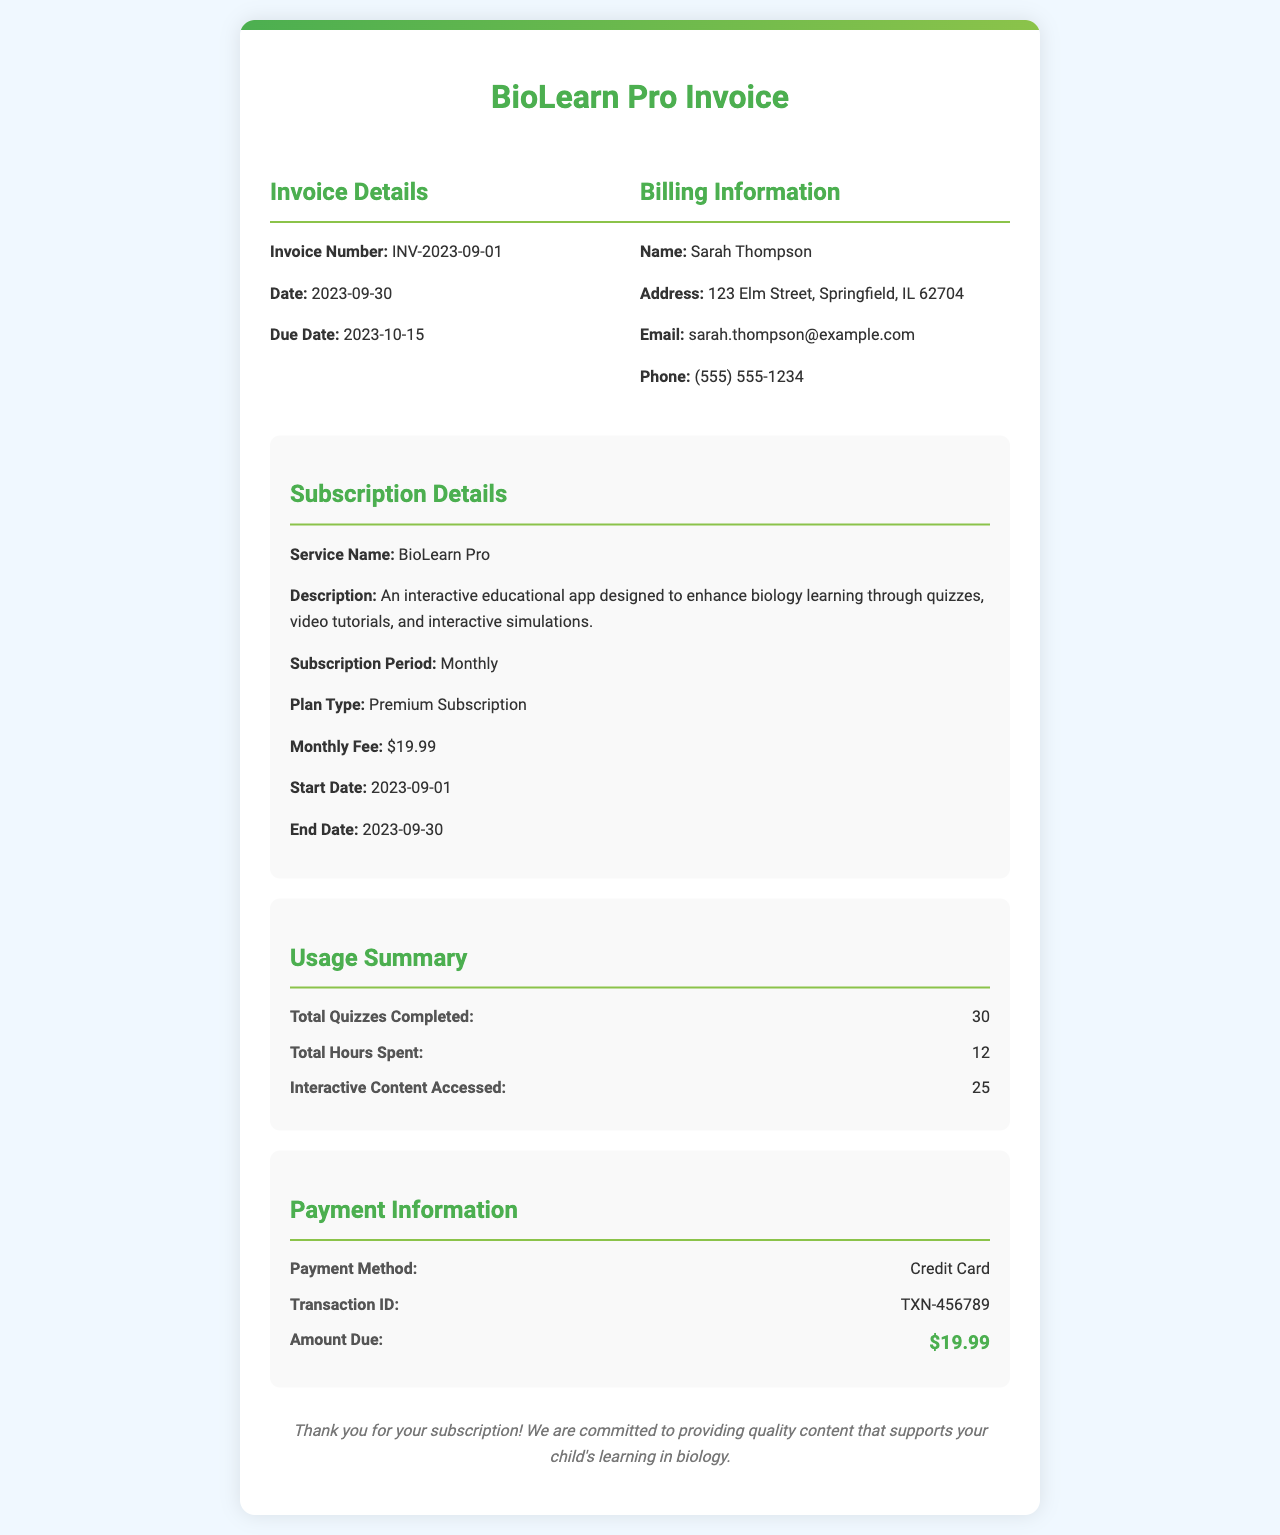What is the invoice number? The invoice number is specified in the document as a unique identifier for this transaction.
Answer: INV-2023-09-01 What is the due date? The due date is when the payment should be made, as indicated in the invoice.
Answer: 2023-10-15 Who is the billing information addressed to? The document provides the name under the billing information section.
Answer: Sarah Thompson What is the monthly fee for the subscription? The fee for the subscription is listed in the subscription details section.
Answer: $19.99 How many quizzes were completed? The number of quizzes is detailed in the usage summary of the document.
Answer: 30 What is the plan type? The plan type indicates the level of subscription provided, found in the subscription details.
Answer: Premium Subscription How many hours were spent on the app? The total hours spent is given in the usage summary section of the invoice.
Answer: 12 What payment method was used? The payment method used for this transaction is listed in the payment information.
Answer: Credit Card What is the total amount due? The total amount due is detailed in the payment information section of the invoice.
Answer: $19.99 